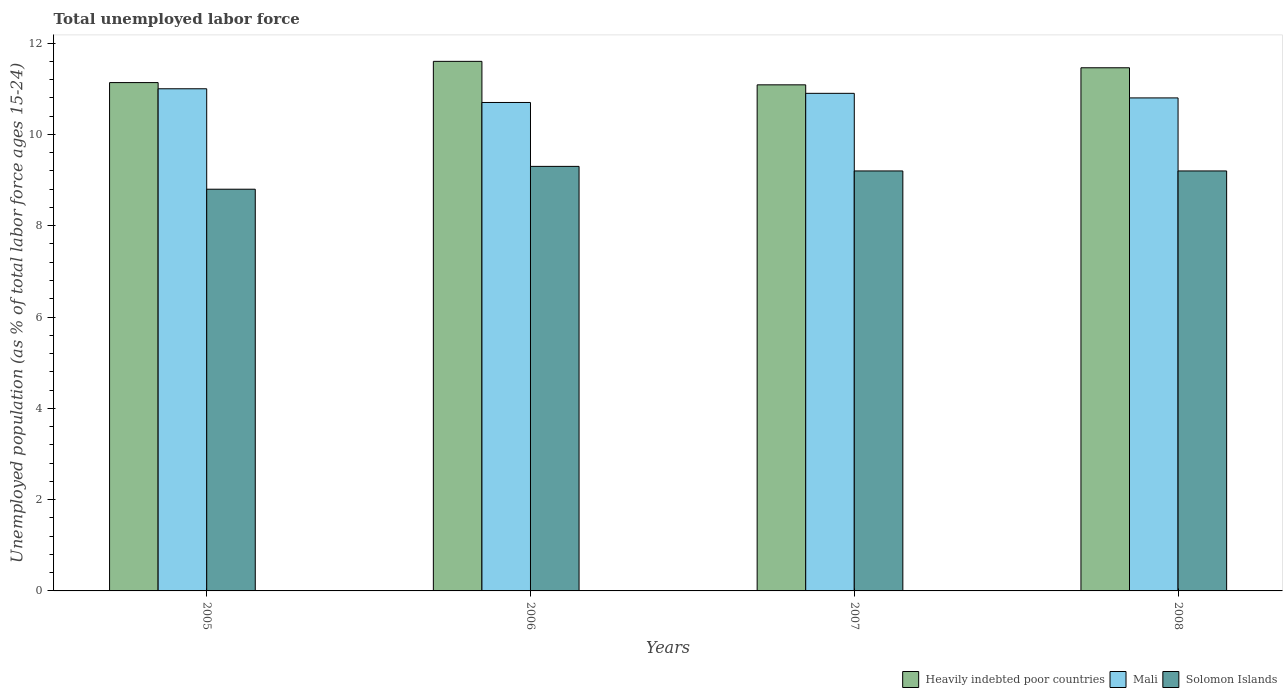How many different coloured bars are there?
Provide a succinct answer. 3. How many groups of bars are there?
Provide a short and direct response. 4. Are the number of bars per tick equal to the number of legend labels?
Make the answer very short. Yes. Are the number of bars on each tick of the X-axis equal?
Provide a succinct answer. Yes. How many bars are there on the 3rd tick from the left?
Your answer should be compact. 3. How many bars are there on the 3rd tick from the right?
Your response must be concise. 3. In how many cases, is the number of bars for a given year not equal to the number of legend labels?
Offer a very short reply. 0. Across all years, what is the maximum percentage of unemployed population in in Solomon Islands?
Provide a short and direct response. 9.3. Across all years, what is the minimum percentage of unemployed population in in Heavily indebted poor countries?
Keep it short and to the point. 11.09. In which year was the percentage of unemployed population in in Solomon Islands minimum?
Your answer should be compact. 2005. What is the total percentage of unemployed population in in Heavily indebted poor countries in the graph?
Provide a succinct answer. 45.28. What is the difference between the percentage of unemployed population in in Heavily indebted poor countries in 2006 and that in 2008?
Your response must be concise. 0.14. What is the difference between the percentage of unemployed population in in Solomon Islands in 2008 and the percentage of unemployed population in in Heavily indebted poor countries in 2005?
Your answer should be very brief. -1.94. What is the average percentage of unemployed population in in Heavily indebted poor countries per year?
Provide a succinct answer. 11.32. In the year 2005, what is the difference between the percentage of unemployed population in in Mali and percentage of unemployed population in in Solomon Islands?
Ensure brevity in your answer.  2.2. In how many years, is the percentage of unemployed population in in Mali greater than 11.2 %?
Ensure brevity in your answer.  0. What is the ratio of the percentage of unemployed population in in Heavily indebted poor countries in 2006 to that in 2007?
Ensure brevity in your answer.  1.05. What is the difference between the highest and the second highest percentage of unemployed population in in Solomon Islands?
Your response must be concise. 0.1. In how many years, is the percentage of unemployed population in in Solomon Islands greater than the average percentage of unemployed population in in Solomon Islands taken over all years?
Give a very brief answer. 3. What does the 3rd bar from the left in 2006 represents?
Ensure brevity in your answer.  Solomon Islands. What does the 2nd bar from the right in 2005 represents?
Offer a very short reply. Mali. Is it the case that in every year, the sum of the percentage of unemployed population in in Solomon Islands and percentage of unemployed population in in Mali is greater than the percentage of unemployed population in in Heavily indebted poor countries?
Your response must be concise. Yes. Are all the bars in the graph horizontal?
Provide a succinct answer. No. What is the difference between two consecutive major ticks on the Y-axis?
Keep it short and to the point. 2. Are the values on the major ticks of Y-axis written in scientific E-notation?
Ensure brevity in your answer.  No. Does the graph contain grids?
Keep it short and to the point. No. Where does the legend appear in the graph?
Offer a terse response. Bottom right. What is the title of the graph?
Give a very brief answer. Total unemployed labor force. Does "North America" appear as one of the legend labels in the graph?
Provide a short and direct response. No. What is the label or title of the X-axis?
Make the answer very short. Years. What is the label or title of the Y-axis?
Your answer should be compact. Unemployed population (as % of total labor force ages 15-24). What is the Unemployed population (as % of total labor force ages 15-24) in Heavily indebted poor countries in 2005?
Offer a very short reply. 11.14. What is the Unemployed population (as % of total labor force ages 15-24) in Mali in 2005?
Offer a very short reply. 11. What is the Unemployed population (as % of total labor force ages 15-24) of Solomon Islands in 2005?
Your answer should be compact. 8.8. What is the Unemployed population (as % of total labor force ages 15-24) in Heavily indebted poor countries in 2006?
Offer a very short reply. 11.6. What is the Unemployed population (as % of total labor force ages 15-24) in Mali in 2006?
Provide a short and direct response. 10.7. What is the Unemployed population (as % of total labor force ages 15-24) of Solomon Islands in 2006?
Keep it short and to the point. 9.3. What is the Unemployed population (as % of total labor force ages 15-24) in Heavily indebted poor countries in 2007?
Your answer should be compact. 11.09. What is the Unemployed population (as % of total labor force ages 15-24) in Mali in 2007?
Provide a short and direct response. 10.9. What is the Unemployed population (as % of total labor force ages 15-24) of Solomon Islands in 2007?
Offer a very short reply. 9.2. What is the Unemployed population (as % of total labor force ages 15-24) in Heavily indebted poor countries in 2008?
Your response must be concise. 11.46. What is the Unemployed population (as % of total labor force ages 15-24) in Mali in 2008?
Your answer should be very brief. 10.8. What is the Unemployed population (as % of total labor force ages 15-24) in Solomon Islands in 2008?
Your answer should be compact. 9.2. Across all years, what is the maximum Unemployed population (as % of total labor force ages 15-24) in Heavily indebted poor countries?
Offer a terse response. 11.6. Across all years, what is the maximum Unemployed population (as % of total labor force ages 15-24) in Solomon Islands?
Provide a succinct answer. 9.3. Across all years, what is the minimum Unemployed population (as % of total labor force ages 15-24) of Heavily indebted poor countries?
Provide a succinct answer. 11.09. Across all years, what is the minimum Unemployed population (as % of total labor force ages 15-24) in Mali?
Provide a short and direct response. 10.7. Across all years, what is the minimum Unemployed population (as % of total labor force ages 15-24) in Solomon Islands?
Your answer should be compact. 8.8. What is the total Unemployed population (as % of total labor force ages 15-24) in Heavily indebted poor countries in the graph?
Keep it short and to the point. 45.28. What is the total Unemployed population (as % of total labor force ages 15-24) in Mali in the graph?
Your answer should be compact. 43.4. What is the total Unemployed population (as % of total labor force ages 15-24) of Solomon Islands in the graph?
Ensure brevity in your answer.  36.5. What is the difference between the Unemployed population (as % of total labor force ages 15-24) of Heavily indebted poor countries in 2005 and that in 2006?
Offer a terse response. -0.47. What is the difference between the Unemployed population (as % of total labor force ages 15-24) of Solomon Islands in 2005 and that in 2006?
Your answer should be compact. -0.5. What is the difference between the Unemployed population (as % of total labor force ages 15-24) in Heavily indebted poor countries in 2005 and that in 2007?
Ensure brevity in your answer.  0.05. What is the difference between the Unemployed population (as % of total labor force ages 15-24) of Solomon Islands in 2005 and that in 2007?
Provide a short and direct response. -0.4. What is the difference between the Unemployed population (as % of total labor force ages 15-24) in Heavily indebted poor countries in 2005 and that in 2008?
Your response must be concise. -0.32. What is the difference between the Unemployed population (as % of total labor force ages 15-24) of Mali in 2005 and that in 2008?
Give a very brief answer. 0.2. What is the difference between the Unemployed population (as % of total labor force ages 15-24) of Heavily indebted poor countries in 2006 and that in 2007?
Ensure brevity in your answer.  0.51. What is the difference between the Unemployed population (as % of total labor force ages 15-24) of Mali in 2006 and that in 2007?
Your answer should be compact. -0.2. What is the difference between the Unemployed population (as % of total labor force ages 15-24) in Solomon Islands in 2006 and that in 2007?
Your answer should be very brief. 0.1. What is the difference between the Unemployed population (as % of total labor force ages 15-24) of Heavily indebted poor countries in 2006 and that in 2008?
Give a very brief answer. 0.14. What is the difference between the Unemployed population (as % of total labor force ages 15-24) in Mali in 2006 and that in 2008?
Offer a very short reply. -0.1. What is the difference between the Unemployed population (as % of total labor force ages 15-24) of Heavily indebted poor countries in 2007 and that in 2008?
Make the answer very short. -0.37. What is the difference between the Unemployed population (as % of total labor force ages 15-24) of Heavily indebted poor countries in 2005 and the Unemployed population (as % of total labor force ages 15-24) of Mali in 2006?
Your answer should be compact. 0.44. What is the difference between the Unemployed population (as % of total labor force ages 15-24) in Heavily indebted poor countries in 2005 and the Unemployed population (as % of total labor force ages 15-24) in Solomon Islands in 2006?
Offer a terse response. 1.84. What is the difference between the Unemployed population (as % of total labor force ages 15-24) of Mali in 2005 and the Unemployed population (as % of total labor force ages 15-24) of Solomon Islands in 2006?
Give a very brief answer. 1.7. What is the difference between the Unemployed population (as % of total labor force ages 15-24) in Heavily indebted poor countries in 2005 and the Unemployed population (as % of total labor force ages 15-24) in Mali in 2007?
Provide a succinct answer. 0.24. What is the difference between the Unemployed population (as % of total labor force ages 15-24) in Heavily indebted poor countries in 2005 and the Unemployed population (as % of total labor force ages 15-24) in Solomon Islands in 2007?
Offer a very short reply. 1.94. What is the difference between the Unemployed population (as % of total labor force ages 15-24) of Mali in 2005 and the Unemployed population (as % of total labor force ages 15-24) of Solomon Islands in 2007?
Your answer should be very brief. 1.8. What is the difference between the Unemployed population (as % of total labor force ages 15-24) in Heavily indebted poor countries in 2005 and the Unemployed population (as % of total labor force ages 15-24) in Mali in 2008?
Your answer should be very brief. 0.34. What is the difference between the Unemployed population (as % of total labor force ages 15-24) in Heavily indebted poor countries in 2005 and the Unemployed population (as % of total labor force ages 15-24) in Solomon Islands in 2008?
Your response must be concise. 1.94. What is the difference between the Unemployed population (as % of total labor force ages 15-24) in Mali in 2005 and the Unemployed population (as % of total labor force ages 15-24) in Solomon Islands in 2008?
Keep it short and to the point. 1.8. What is the difference between the Unemployed population (as % of total labor force ages 15-24) in Heavily indebted poor countries in 2006 and the Unemployed population (as % of total labor force ages 15-24) in Mali in 2007?
Give a very brief answer. 0.7. What is the difference between the Unemployed population (as % of total labor force ages 15-24) of Heavily indebted poor countries in 2006 and the Unemployed population (as % of total labor force ages 15-24) of Solomon Islands in 2007?
Offer a very short reply. 2.4. What is the difference between the Unemployed population (as % of total labor force ages 15-24) of Heavily indebted poor countries in 2006 and the Unemployed population (as % of total labor force ages 15-24) of Mali in 2008?
Your answer should be very brief. 0.8. What is the difference between the Unemployed population (as % of total labor force ages 15-24) in Heavily indebted poor countries in 2006 and the Unemployed population (as % of total labor force ages 15-24) in Solomon Islands in 2008?
Provide a short and direct response. 2.4. What is the difference between the Unemployed population (as % of total labor force ages 15-24) of Mali in 2006 and the Unemployed population (as % of total labor force ages 15-24) of Solomon Islands in 2008?
Your response must be concise. 1.5. What is the difference between the Unemployed population (as % of total labor force ages 15-24) in Heavily indebted poor countries in 2007 and the Unemployed population (as % of total labor force ages 15-24) in Mali in 2008?
Make the answer very short. 0.29. What is the difference between the Unemployed population (as % of total labor force ages 15-24) of Heavily indebted poor countries in 2007 and the Unemployed population (as % of total labor force ages 15-24) of Solomon Islands in 2008?
Give a very brief answer. 1.89. What is the difference between the Unemployed population (as % of total labor force ages 15-24) of Mali in 2007 and the Unemployed population (as % of total labor force ages 15-24) of Solomon Islands in 2008?
Your answer should be compact. 1.7. What is the average Unemployed population (as % of total labor force ages 15-24) in Heavily indebted poor countries per year?
Make the answer very short. 11.32. What is the average Unemployed population (as % of total labor force ages 15-24) in Mali per year?
Give a very brief answer. 10.85. What is the average Unemployed population (as % of total labor force ages 15-24) of Solomon Islands per year?
Your answer should be very brief. 9.12. In the year 2005, what is the difference between the Unemployed population (as % of total labor force ages 15-24) in Heavily indebted poor countries and Unemployed population (as % of total labor force ages 15-24) in Mali?
Keep it short and to the point. 0.14. In the year 2005, what is the difference between the Unemployed population (as % of total labor force ages 15-24) in Heavily indebted poor countries and Unemployed population (as % of total labor force ages 15-24) in Solomon Islands?
Your answer should be very brief. 2.34. In the year 2005, what is the difference between the Unemployed population (as % of total labor force ages 15-24) in Mali and Unemployed population (as % of total labor force ages 15-24) in Solomon Islands?
Offer a terse response. 2.2. In the year 2006, what is the difference between the Unemployed population (as % of total labor force ages 15-24) of Heavily indebted poor countries and Unemployed population (as % of total labor force ages 15-24) of Mali?
Your response must be concise. 0.9. In the year 2006, what is the difference between the Unemployed population (as % of total labor force ages 15-24) of Heavily indebted poor countries and Unemployed population (as % of total labor force ages 15-24) of Solomon Islands?
Your response must be concise. 2.3. In the year 2007, what is the difference between the Unemployed population (as % of total labor force ages 15-24) of Heavily indebted poor countries and Unemployed population (as % of total labor force ages 15-24) of Mali?
Offer a very short reply. 0.19. In the year 2007, what is the difference between the Unemployed population (as % of total labor force ages 15-24) in Heavily indebted poor countries and Unemployed population (as % of total labor force ages 15-24) in Solomon Islands?
Your answer should be very brief. 1.89. In the year 2007, what is the difference between the Unemployed population (as % of total labor force ages 15-24) in Mali and Unemployed population (as % of total labor force ages 15-24) in Solomon Islands?
Provide a succinct answer. 1.7. In the year 2008, what is the difference between the Unemployed population (as % of total labor force ages 15-24) in Heavily indebted poor countries and Unemployed population (as % of total labor force ages 15-24) in Mali?
Provide a succinct answer. 0.66. In the year 2008, what is the difference between the Unemployed population (as % of total labor force ages 15-24) in Heavily indebted poor countries and Unemployed population (as % of total labor force ages 15-24) in Solomon Islands?
Your answer should be compact. 2.26. In the year 2008, what is the difference between the Unemployed population (as % of total labor force ages 15-24) of Mali and Unemployed population (as % of total labor force ages 15-24) of Solomon Islands?
Keep it short and to the point. 1.6. What is the ratio of the Unemployed population (as % of total labor force ages 15-24) of Heavily indebted poor countries in 2005 to that in 2006?
Make the answer very short. 0.96. What is the ratio of the Unemployed population (as % of total labor force ages 15-24) of Mali in 2005 to that in 2006?
Offer a very short reply. 1.03. What is the ratio of the Unemployed population (as % of total labor force ages 15-24) in Solomon Islands in 2005 to that in 2006?
Keep it short and to the point. 0.95. What is the ratio of the Unemployed population (as % of total labor force ages 15-24) of Mali in 2005 to that in 2007?
Provide a succinct answer. 1.01. What is the ratio of the Unemployed population (as % of total labor force ages 15-24) in Solomon Islands in 2005 to that in 2007?
Your response must be concise. 0.96. What is the ratio of the Unemployed population (as % of total labor force ages 15-24) in Heavily indebted poor countries in 2005 to that in 2008?
Ensure brevity in your answer.  0.97. What is the ratio of the Unemployed population (as % of total labor force ages 15-24) of Mali in 2005 to that in 2008?
Your answer should be very brief. 1.02. What is the ratio of the Unemployed population (as % of total labor force ages 15-24) of Solomon Islands in 2005 to that in 2008?
Keep it short and to the point. 0.96. What is the ratio of the Unemployed population (as % of total labor force ages 15-24) in Heavily indebted poor countries in 2006 to that in 2007?
Keep it short and to the point. 1.05. What is the ratio of the Unemployed population (as % of total labor force ages 15-24) of Mali in 2006 to that in 2007?
Provide a short and direct response. 0.98. What is the ratio of the Unemployed population (as % of total labor force ages 15-24) in Solomon Islands in 2006 to that in 2007?
Offer a very short reply. 1.01. What is the ratio of the Unemployed population (as % of total labor force ages 15-24) in Heavily indebted poor countries in 2006 to that in 2008?
Your answer should be compact. 1.01. What is the ratio of the Unemployed population (as % of total labor force ages 15-24) of Solomon Islands in 2006 to that in 2008?
Provide a short and direct response. 1.01. What is the ratio of the Unemployed population (as % of total labor force ages 15-24) of Heavily indebted poor countries in 2007 to that in 2008?
Provide a succinct answer. 0.97. What is the ratio of the Unemployed population (as % of total labor force ages 15-24) of Mali in 2007 to that in 2008?
Offer a terse response. 1.01. What is the difference between the highest and the second highest Unemployed population (as % of total labor force ages 15-24) in Heavily indebted poor countries?
Offer a very short reply. 0.14. What is the difference between the highest and the second highest Unemployed population (as % of total labor force ages 15-24) of Mali?
Make the answer very short. 0.1. What is the difference between the highest and the second highest Unemployed population (as % of total labor force ages 15-24) of Solomon Islands?
Offer a terse response. 0.1. What is the difference between the highest and the lowest Unemployed population (as % of total labor force ages 15-24) of Heavily indebted poor countries?
Keep it short and to the point. 0.51. What is the difference between the highest and the lowest Unemployed population (as % of total labor force ages 15-24) in Solomon Islands?
Ensure brevity in your answer.  0.5. 